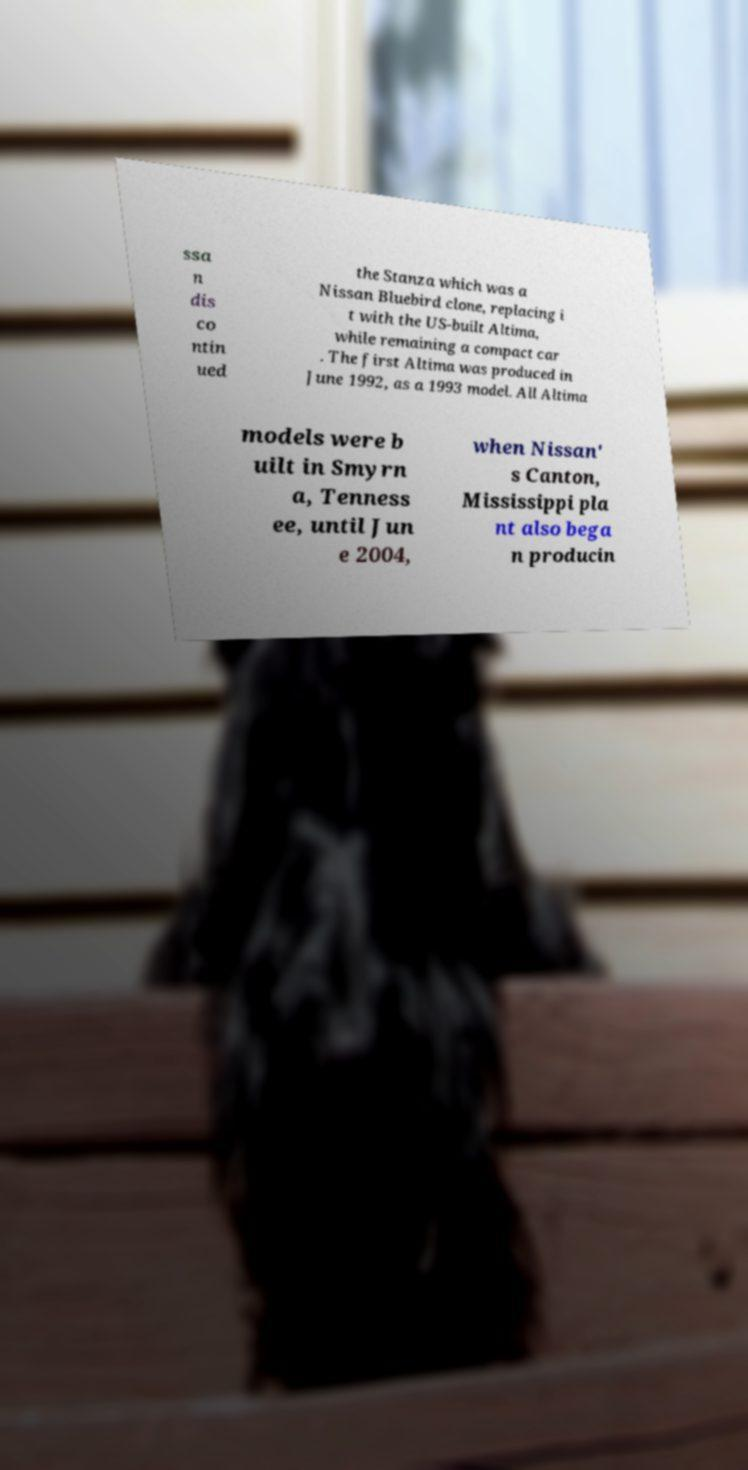Could you assist in decoding the text presented in this image and type it out clearly? ssa n dis co ntin ued the Stanza which was a Nissan Bluebird clone, replacing i t with the US-built Altima, while remaining a compact car . The first Altima was produced in June 1992, as a 1993 model. All Altima models were b uilt in Smyrn a, Tenness ee, until Jun e 2004, when Nissan' s Canton, Mississippi pla nt also bega n producin 